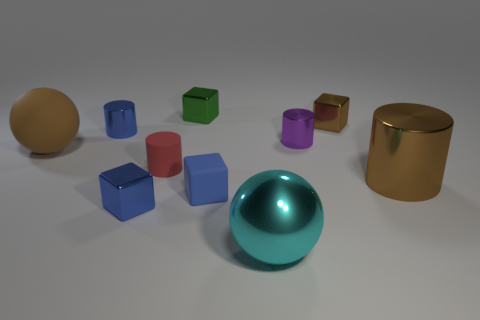Subtract all blue cubes. How many were subtracted if there are1blue cubes left? 1 Subtract all brown spheres. How many spheres are left? 1 Subtract all small rubber cylinders. How many cylinders are left? 3 Subtract all spheres. How many objects are left? 8 Subtract all big blue metal cylinders. Subtract all blue blocks. How many objects are left? 8 Add 1 cyan shiny balls. How many cyan shiny balls are left? 2 Add 5 small red matte cylinders. How many small red matte cylinders exist? 6 Subtract 0 green cylinders. How many objects are left? 10 Subtract 1 cylinders. How many cylinders are left? 3 Subtract all blue cylinders. Subtract all cyan balls. How many cylinders are left? 3 